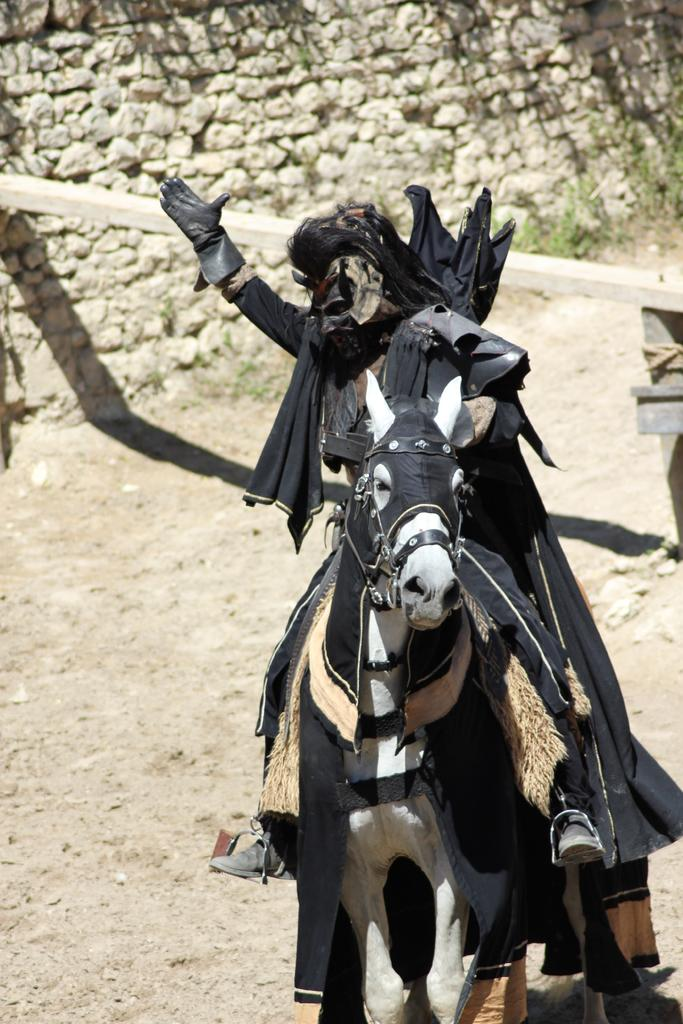What is the main subject of the image? There is a person in the image. What is the person wearing? The person is wearing a mask. What is the person doing in the image? The person is on a horse. What can be seen in the background of the image? There is a stone wall in the background of the image. What type of bread is the person holding in the image? There is no bread present in the image. What toys can be seen on the horse in the image? There are no toys visible in the image; the person is simply riding the horse. 